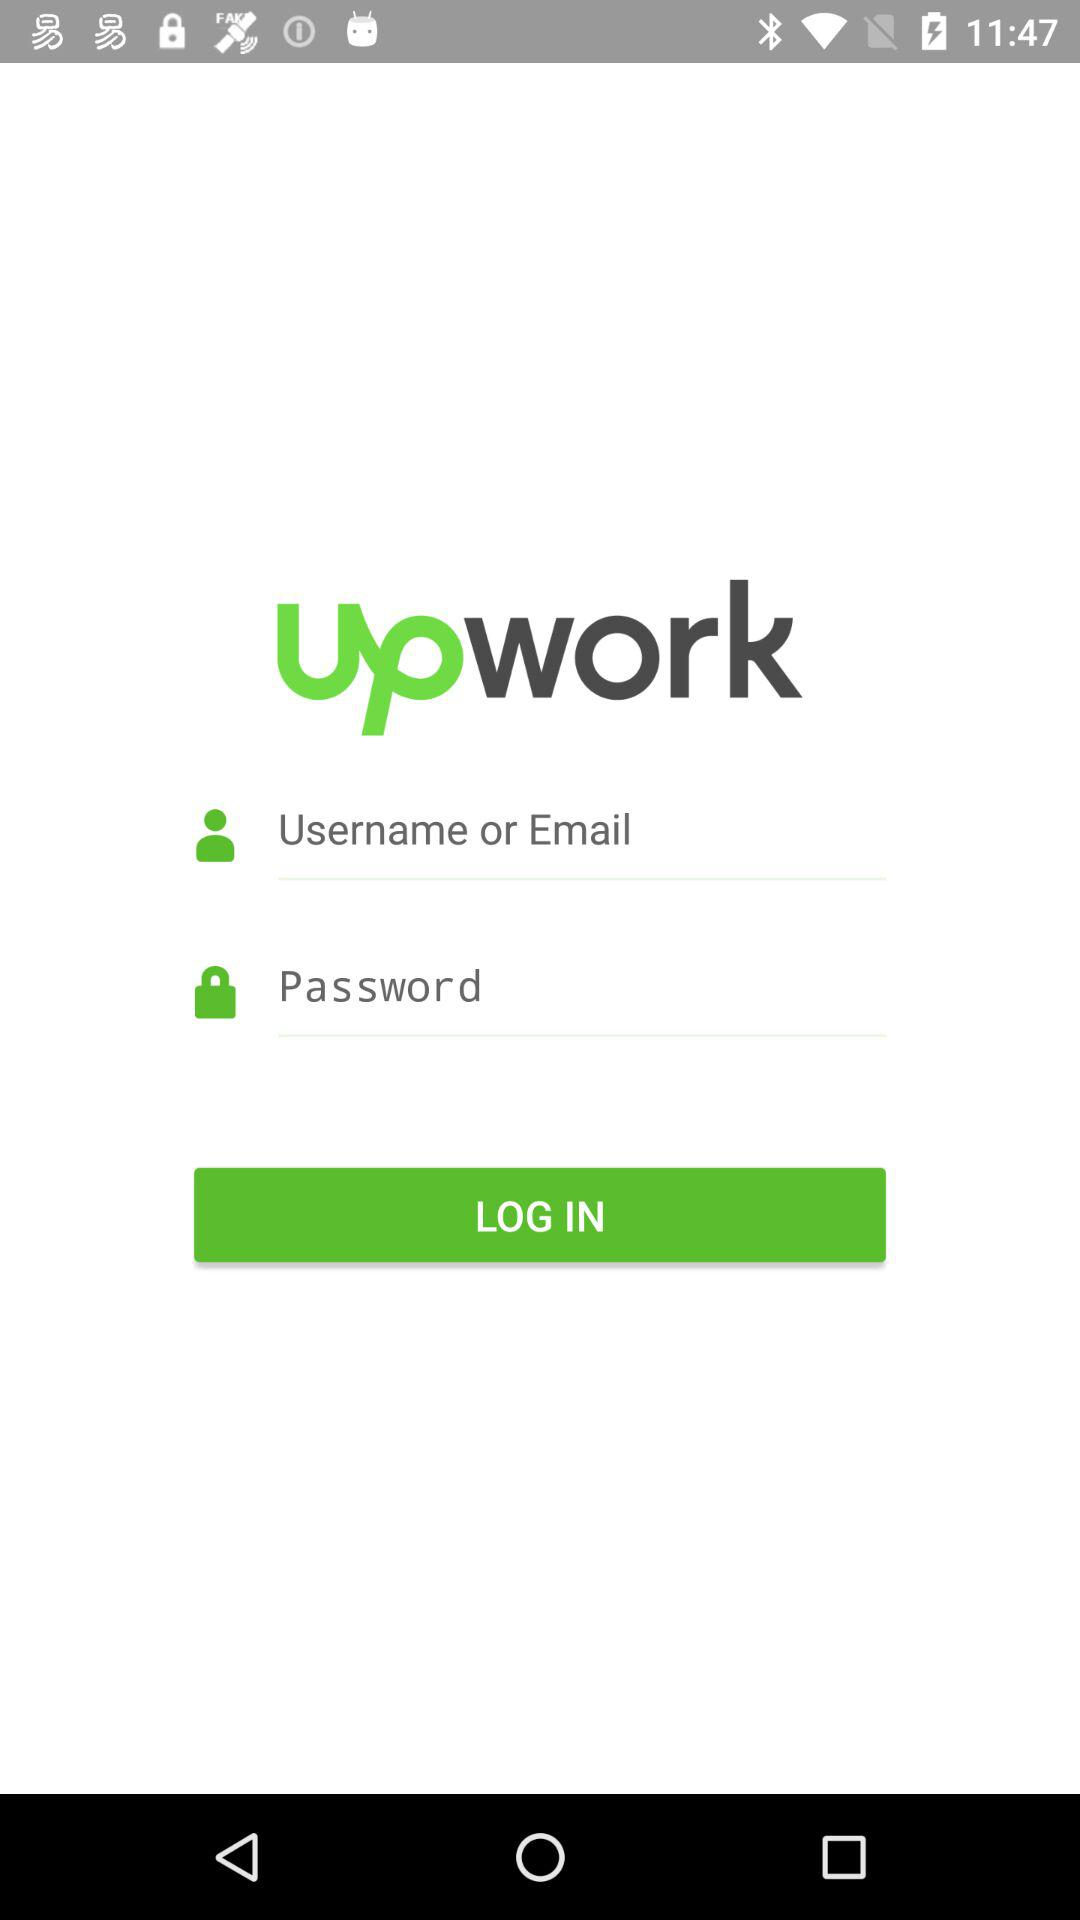What is the app name? The app name is "upwork". 